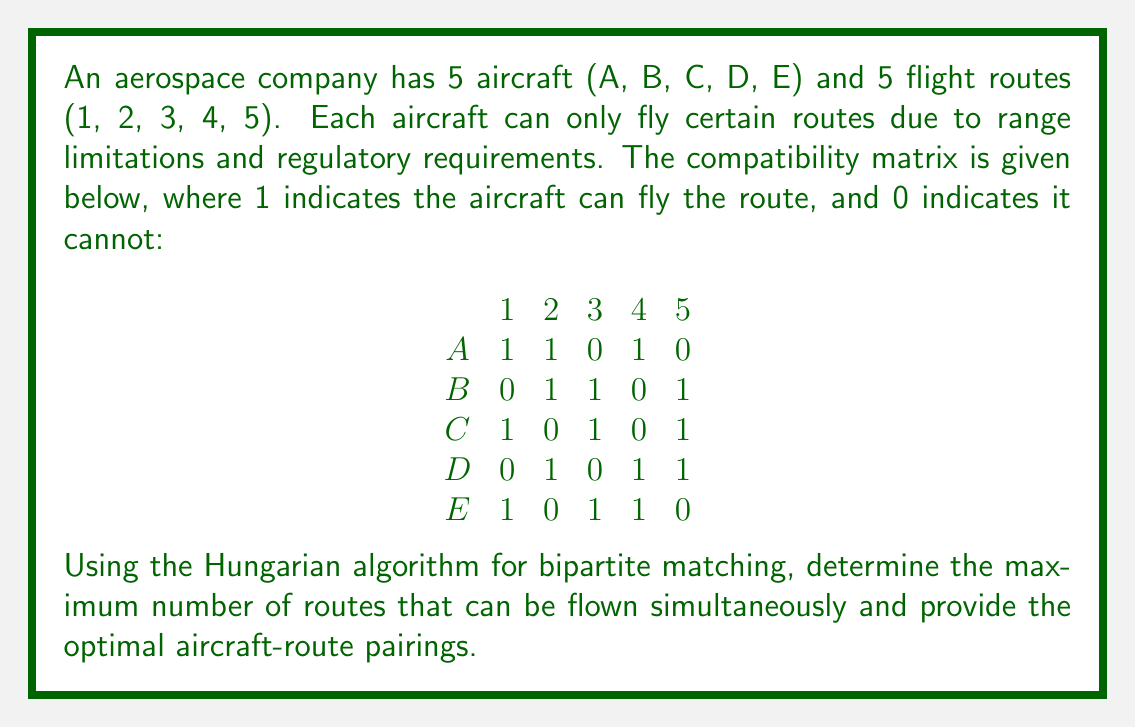Can you answer this question? To solve this problem using the Hungarian algorithm for bipartite matching, we'll follow these steps:

1) First, we need to create a bipartite graph from the given compatibility matrix. The aircraft will be on one side of the graph, and the routes will be on the other side. An edge exists between an aircraft and a route if there's a 1 in the corresponding cell of the matrix.

2) The Hungarian algorithm works on a cost matrix, where we typically minimize the cost. In our case, we want to maximize the number of matches, so we'll convert our compatibility matrix to a cost matrix by subtracting each element from 1:

$$
\begin{matrix}
& 1 & 2 & 3 & 4 & 5 \\
A & 0 & 0 & 1 & 0 & 1 \\
B & 1 & 0 & 0 & 1 & 0 \\
C & 0 & 1 & 0 & 1 & 0 \\
D & 1 & 0 & 1 & 0 & 0 \\
E & 0 & 1 & 0 & 0 & 1
\end{matrix}
$$

3) Now we apply the Hungarian algorithm:

   a) Subtract the minimum value in each row from every element in that row:
   $$
   \begin{matrix}
   & 1 & 2 & 3 & 4 & 5 \\
   A & 0 & 0 & 1 & 0 & 1 \\
   B & 1 & 0 & 0 & 1 & 0 \\
   C & 0 & 1 & 0 & 1 & 0 \\
   D & 1 & 0 & 1 & 0 & 0 \\
   E & 0 & 1 & 0 & 0 & 1
   \end{matrix}
   $$

   b) Subtract the minimum value in each column from every element in that column:
   $$
   \begin{matrix}
   & 1 & 2 & 3 & 4 & 5 \\
   A & 0 & 0 & 1 & 0 & 1 \\
   B & 1 & 0 & 0 & 1 & 0 \\
   C & 0 & 1 & 0 & 1 & 0 \\
   D & 1 & 0 & 1 & 0 & 0 \\
   E & 0 & 1 & 0 & 0 & 1
   \end{matrix}
   $$

4) Now, we need to find the minimum number of lines (horizontal or vertical) to cover all zeros in the matrix. We can do this by finding a maximum matching in the bipartite graph represented by the zeros:

   A - 1, B - 3, C - 1, D - 5, E - 4

   This gives us 5 lines, which is equal to the number of rows/columns. Therefore, we have found an optimal solution.

5) The optimal matching is:
   Aircraft A - Route 1
   Aircraft B - Route 3
   Aircraft C - Route 5
   Aircraft D - Route 2
   Aircraft E - Route 4

This matching allows all 5 routes to be flown simultaneously, which is the maximum possible given that we have 5 aircraft and 5 routes.
Answer: The maximum number of routes that can be flown simultaneously is 5. The optimal aircraft-route pairings are:
A-1, B-3, C-5, D-2, E-4 